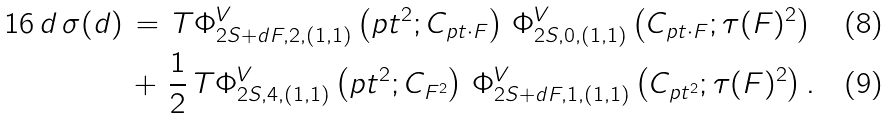<formula> <loc_0><loc_0><loc_500><loc_500>1 6 \, d \, \sigma ( d ) \, & = \, T \Phi _ { 2 S + d F , 2 , ( 1 , 1 ) } ^ { V } \left ( p t ^ { 2 } ; C _ { p t \cdot F } \right ) \, \Phi _ { 2 S , 0 , ( 1 , 1 ) } ^ { V } \left ( C _ { p t \cdot F } ; \tau ( F ) ^ { 2 } \right ) \\ & + \, \frac { 1 } { 2 } \, T \Phi _ { 2 S , 4 , ( 1 , 1 ) } ^ { V } \left ( p t ^ { 2 } ; C _ { F ^ { 2 } } \right ) \, \Phi _ { 2 S + d F , 1 , ( 1 , 1 ) } ^ { V } \left ( C _ { p t ^ { 2 } } ; \tau ( F ) ^ { 2 } \right ) .</formula> 